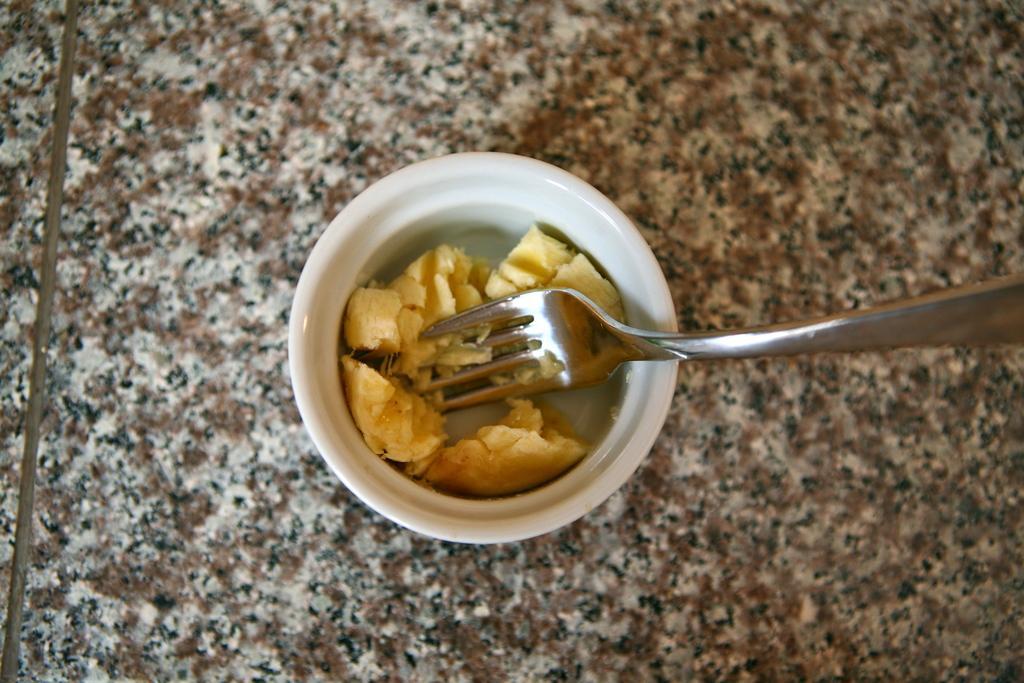Can you describe this image briefly? In this picture we can see some food item in a small white bowl & a fork kept on the floor. 